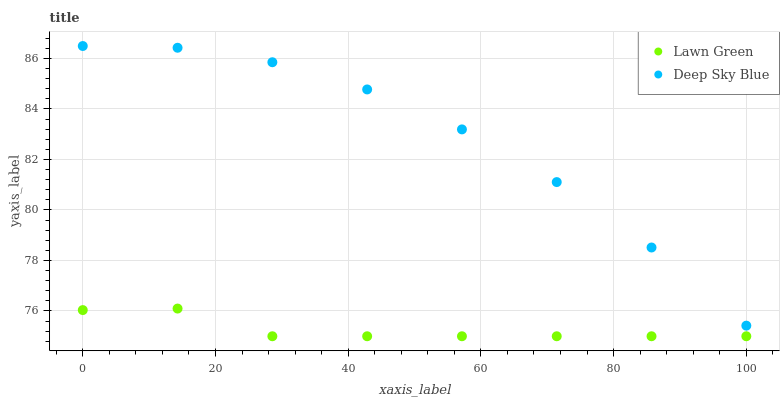Does Lawn Green have the minimum area under the curve?
Answer yes or no. Yes. Does Deep Sky Blue have the maximum area under the curve?
Answer yes or no. Yes. Does Deep Sky Blue have the minimum area under the curve?
Answer yes or no. No. Is Lawn Green the smoothest?
Answer yes or no. Yes. Is Deep Sky Blue the roughest?
Answer yes or no. Yes. Is Deep Sky Blue the smoothest?
Answer yes or no. No. Does Lawn Green have the lowest value?
Answer yes or no. Yes. Does Deep Sky Blue have the lowest value?
Answer yes or no. No. Does Deep Sky Blue have the highest value?
Answer yes or no. Yes. Is Lawn Green less than Deep Sky Blue?
Answer yes or no. Yes. Is Deep Sky Blue greater than Lawn Green?
Answer yes or no. Yes. Does Lawn Green intersect Deep Sky Blue?
Answer yes or no. No. 